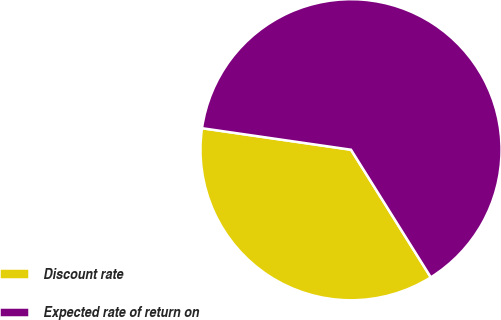Convert chart. <chart><loc_0><loc_0><loc_500><loc_500><pie_chart><fcel>Discount rate<fcel>Expected rate of return on<nl><fcel>36.18%<fcel>63.82%<nl></chart> 